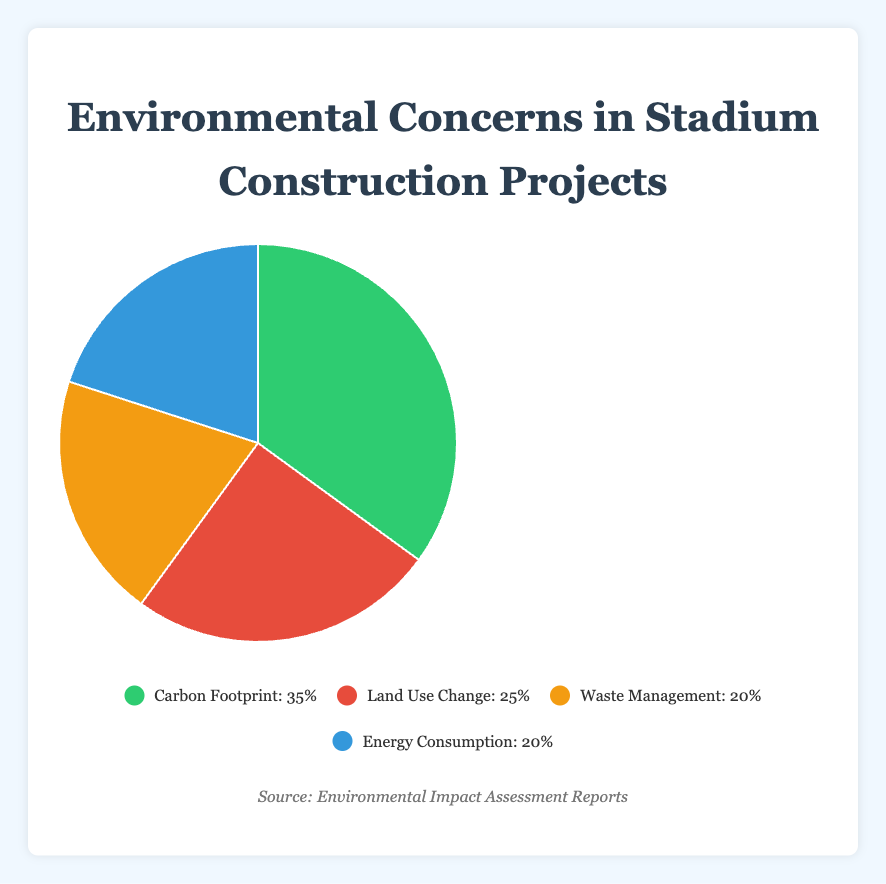What is the most significant environmental concern in stadium construction according to the pie chart? From the pie chart, the largest section corresponds to Carbon Footprint, which takes up 35% of the whole. This indicates that Carbon Footprint is the most significant concern.
Answer: Carbon Footprint How do the percentages of Waste Management and Energy Consumption compare? The pie chart shows that both Waste Management and Energy Consumption each occupy 20% of the total, meaning they are equal in terms of their percentage share.
Answer: They are equal Which environmental concern is represented by the green segment in the pie chart? The green segment of the pie chart corresponds to Carbon Footprint, as indicated in the legend.
Answer: Carbon Footprint What is the combined percentage for Land Use Change and Energy Consumption? The pie chart shows Land Use Change at 25% and Energy Consumption at 20%. Adding these together gives 25% + 20% = 45%.
Answer: 45% Among the concerns listed, which one occupies the smallest share of the pie chart? The pie chart shows that both Waste Management and Energy Consumption are the smallest, each occupying 20%.
Answer: Waste Management and Energy Consumption If you were to combine the percentages of Carbon Footprint and Land Use Change, what would be their total share? The pie chart shows Carbon Footprint at 35% and Land Use Change at 25%. Adding these gives 35% + 25% = 60%.
Answer: 60% Comparing Carbon Footprint and Land Use Change, what is the percentage difference between them? The percentage for Carbon Footprint is 35% and for Land Use Change is 25%. The difference is 35% - 25% = 10%.
Answer: 10% If a new stadium is constructed and efforts are made to reduce Waste Management by half, what would be the new percentage for Waste Management? The current percentage for Waste Management is 20%. Reducing it by half means it would be 20% / 2 = 10%.
Answer: 10% 